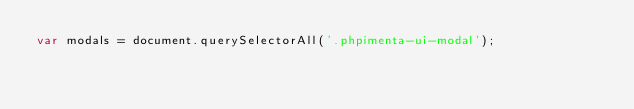<code> <loc_0><loc_0><loc_500><loc_500><_JavaScript_>var modals = document.querySelectorAll('.phpimenta-ui-modal');
</code> 